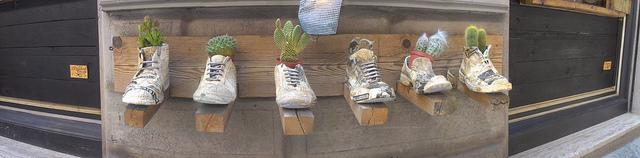Which shoes require watering more than daily?

Choices:
A) right ones
B) none
C) all
D) left ones none 